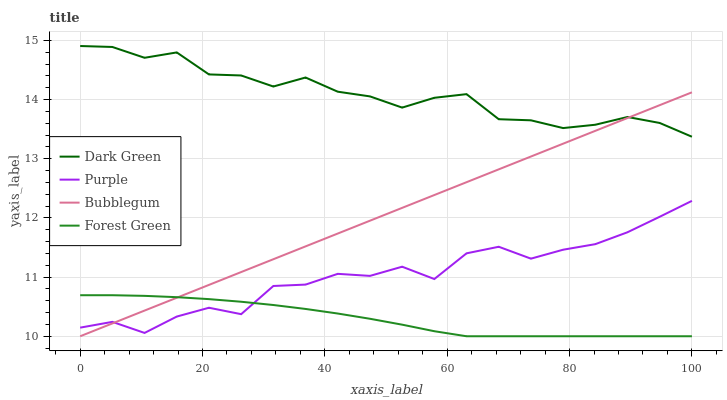Does Forest Green have the minimum area under the curve?
Answer yes or no. Yes. Does Dark Green have the maximum area under the curve?
Answer yes or no. Yes. Does Bubblegum have the minimum area under the curve?
Answer yes or no. No. Does Bubblegum have the maximum area under the curve?
Answer yes or no. No. Is Bubblegum the smoothest?
Answer yes or no. Yes. Is Purple the roughest?
Answer yes or no. Yes. Is Forest Green the smoothest?
Answer yes or no. No. Is Forest Green the roughest?
Answer yes or no. No. Does Forest Green have the lowest value?
Answer yes or no. Yes. Does Dark Green have the lowest value?
Answer yes or no. No. Does Dark Green have the highest value?
Answer yes or no. Yes. Does Bubblegum have the highest value?
Answer yes or no. No. Is Forest Green less than Dark Green?
Answer yes or no. Yes. Is Dark Green greater than Forest Green?
Answer yes or no. Yes. Does Purple intersect Bubblegum?
Answer yes or no. Yes. Is Purple less than Bubblegum?
Answer yes or no. No. Is Purple greater than Bubblegum?
Answer yes or no. No. Does Forest Green intersect Dark Green?
Answer yes or no. No. 